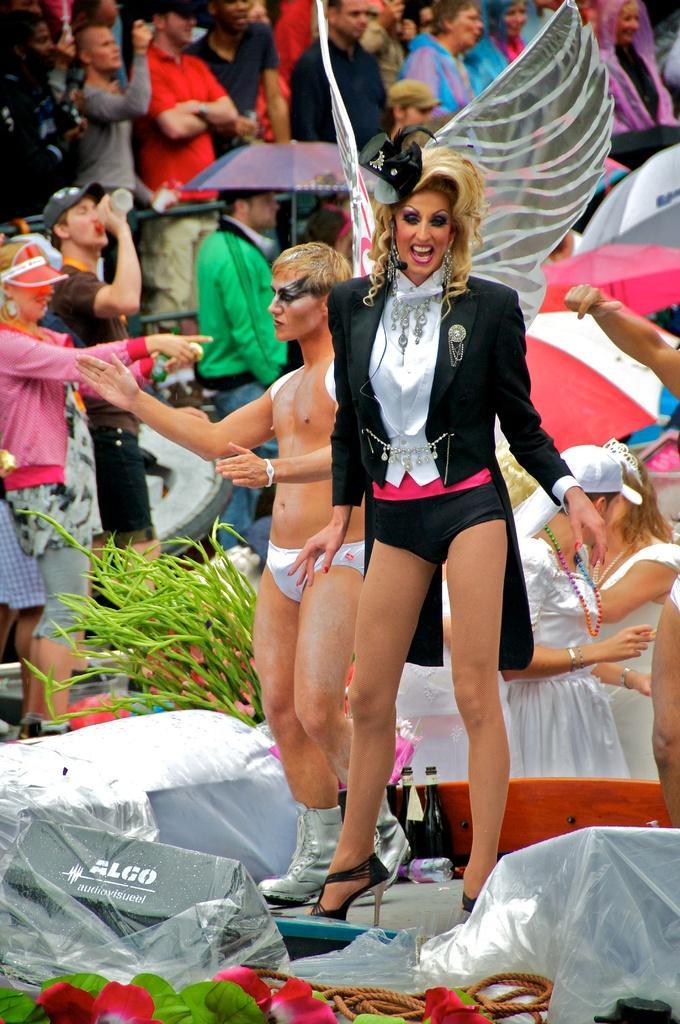In one or two sentences, can you explain what this image depicts? In this image we can see a few people, among them some people are holding the objects, there are some bottles, flowers, umbrellas, rope, plant and some other objects. 